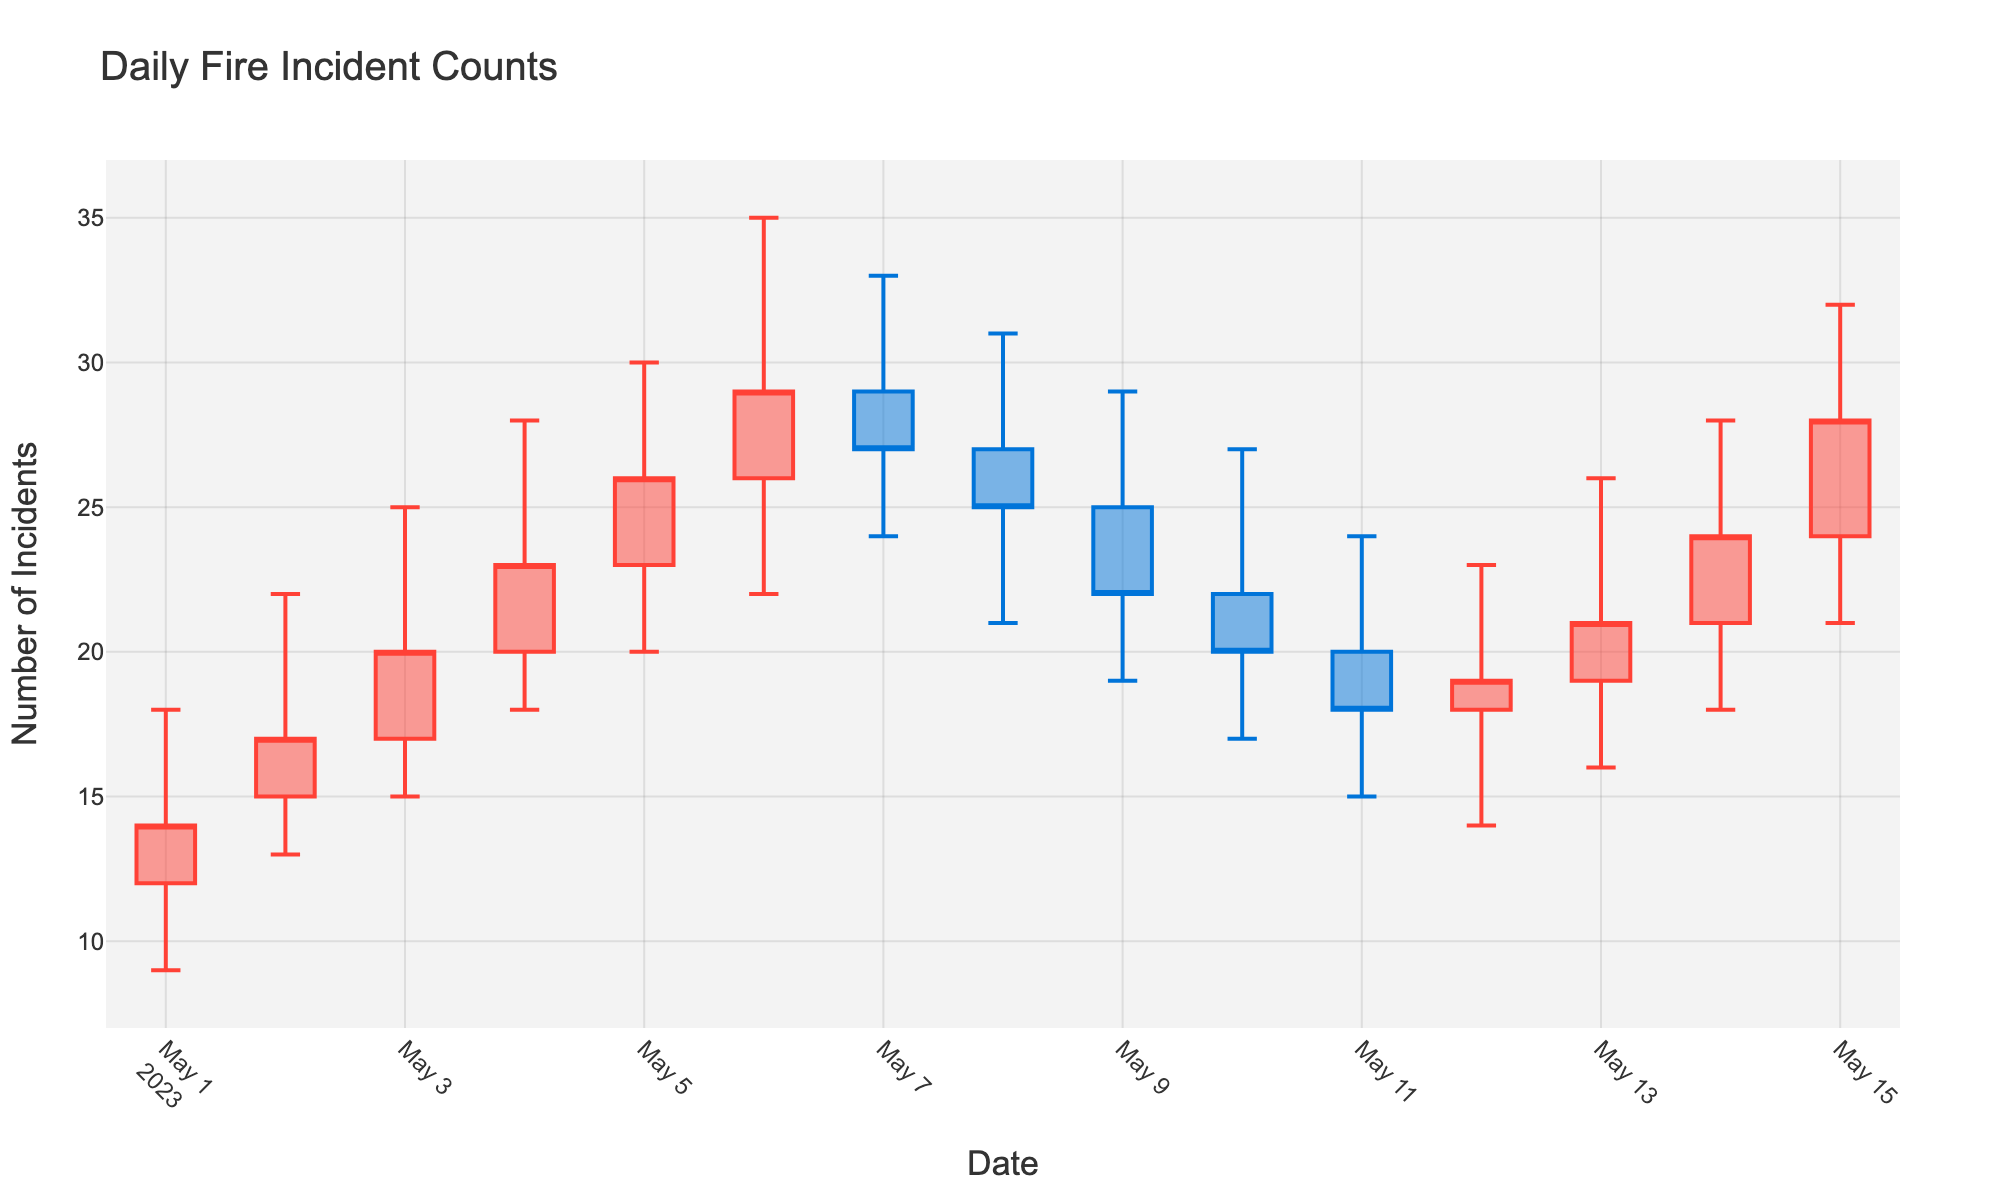How many days of data are displayed in the OHLC chart? The chart displays daily fire incident counts for each day from May 1 to May 15, which totals 15 days
Answer: 15 On which date did the highest daily incident count occur? By observing the chart, we can see that the highest daily incident count, represented by the highest "high" value, is on May 6
Answer: May 6 What is the range of incident counts on May 4? The range of incident counts is calculated by subtracting the lowest count from the highest count on May 4, which are 28 and 18 respectively. So, 28 - 18 = 10
Answer: 10 Was there an increase or decrease in the closing count from May 7 to May 8? Comparing the closing counts of May 7 and May 8, we see the count decreased from 27 to 25
Answer: Decrease What is the average high count over the period? Summing the high counts (18, 22, 25, 28, 30, 35, 33, 31, 29, 27, 24, 23, 26, 28, 32) and dividing by the number of days (15) gives (18+22+25+28+30+35+33+31+29+27+24+23+26+28+32)/15 = 27.47
Answer: 27.47 Which day has the smallest range between its high and low counts? By calculating the range (high-low) for each day and comparing, we see that the smallest range is on May 7 with a high of 33 and a low of 24, making the range 33 - 24 = 9
Answer: May 7 On which date did the count open higher than it closed? Comparing the open and close values, May 7's count opened at 29 and closed at 27, showing it opened higher than it closed
Answer: May 7 How many times did the closing count end higher than the opening count during the period? By comparing the close and open values for each day in the data, we find that the close count is higher than the open count on May 1, May 2, May 3, May 4, May 5, May 6, May 10, May 12, May 13, and May 14. This occurred 10 times
Answer: 10 Which day had the greatest increase in incident count within a single day? By looking at the difference between the high and low counts for each day, May 6 had the greatest increase with a high of 35 and a low of 22, a difference of 13
Answer: May 6 